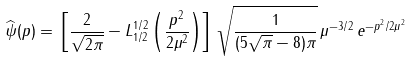Convert formula to latex. <formula><loc_0><loc_0><loc_500><loc_500>\widehat { \psi } ( p ) = \, \left [ \frac { 2 } { \sqrt { 2 \pi } } - L ^ { 1 / 2 } _ { 1 / 2 } \left ( \frac { p ^ { 2 } } { 2 \mu ^ { 2 } } \right ) \right ] \, \sqrt { \frac { 1 } { ( 5 \sqrt { \pi } - 8 ) \pi } } \, \mu ^ { - 3 / 2 } \, e ^ { - p ^ { 2 } / 2 \mu ^ { 2 } }</formula> 